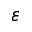Convert formula to latex. <formula><loc_0><loc_0><loc_500><loc_500>\varepsilon</formula> 